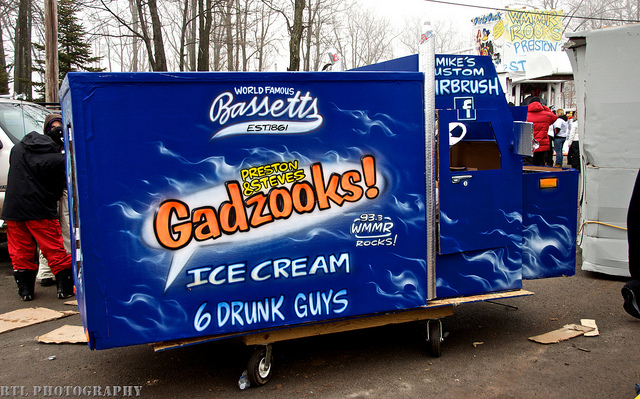Read all the text in this image. CREAM EST1861 ICE DRUNK Guys 6 PHOTOGRAPHY RTI RBRUSH ustom MIKE'S ST PRESTON ROOMS WMMR ROCKS WMMR 93.3 Gadzooks! &amp;STEVES PRESTON Bassetts FAMOUS WORLD 